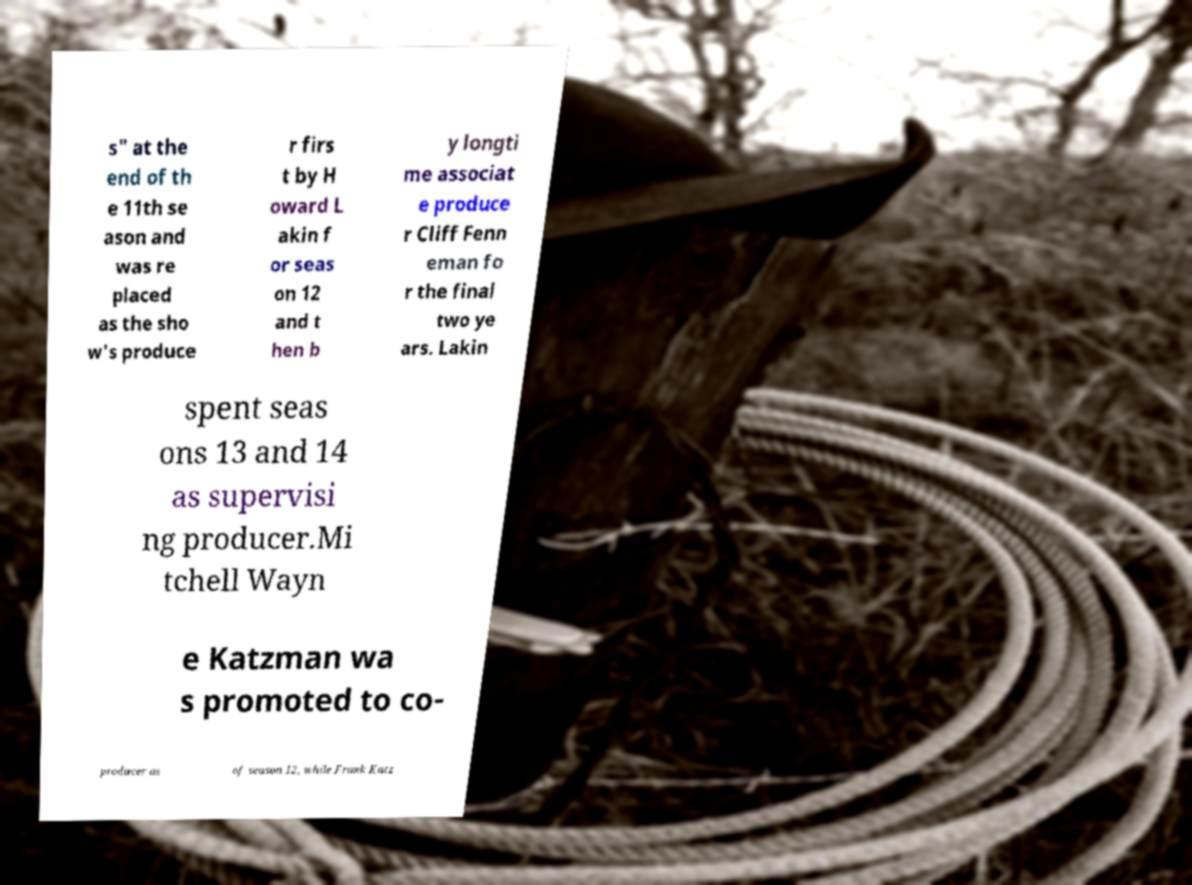Can you accurately transcribe the text from the provided image for me? s" at the end of th e 11th se ason and was re placed as the sho w's produce r firs t by H oward L akin f or seas on 12 and t hen b y longti me associat e produce r Cliff Fenn eman fo r the final two ye ars. Lakin spent seas ons 13 and 14 as supervisi ng producer.Mi tchell Wayn e Katzman wa s promoted to co- producer as of season 12, while Frank Katz 